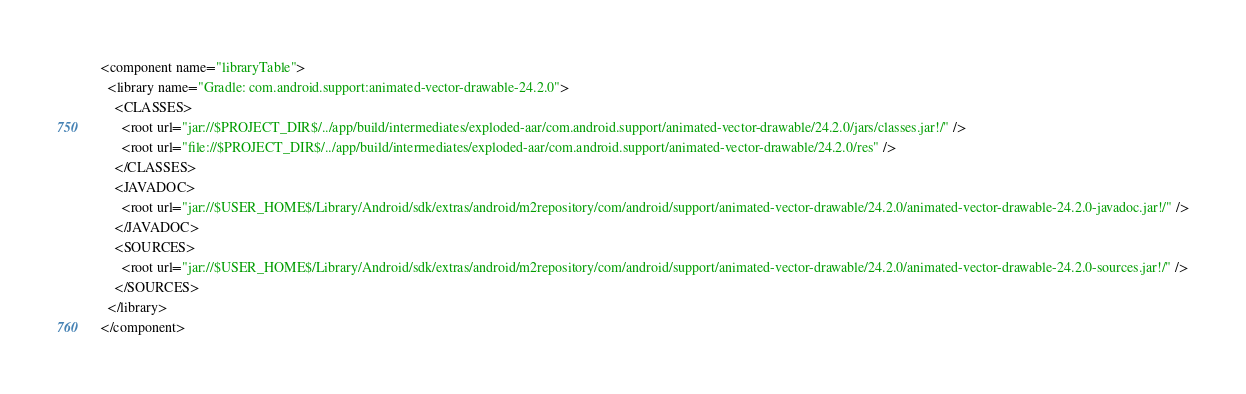Convert code to text. <code><loc_0><loc_0><loc_500><loc_500><_XML_><component name="libraryTable">
  <library name="Gradle: com.android.support:animated-vector-drawable-24.2.0">
    <CLASSES>
      <root url="jar://$PROJECT_DIR$/../app/build/intermediates/exploded-aar/com.android.support/animated-vector-drawable/24.2.0/jars/classes.jar!/" />
      <root url="file://$PROJECT_DIR$/../app/build/intermediates/exploded-aar/com.android.support/animated-vector-drawable/24.2.0/res" />
    </CLASSES>
    <JAVADOC>
      <root url="jar://$USER_HOME$/Library/Android/sdk/extras/android/m2repository/com/android/support/animated-vector-drawable/24.2.0/animated-vector-drawable-24.2.0-javadoc.jar!/" />
    </JAVADOC>
    <SOURCES>
      <root url="jar://$USER_HOME$/Library/Android/sdk/extras/android/m2repository/com/android/support/animated-vector-drawable/24.2.0/animated-vector-drawable-24.2.0-sources.jar!/" />
    </SOURCES>
  </library>
</component></code> 